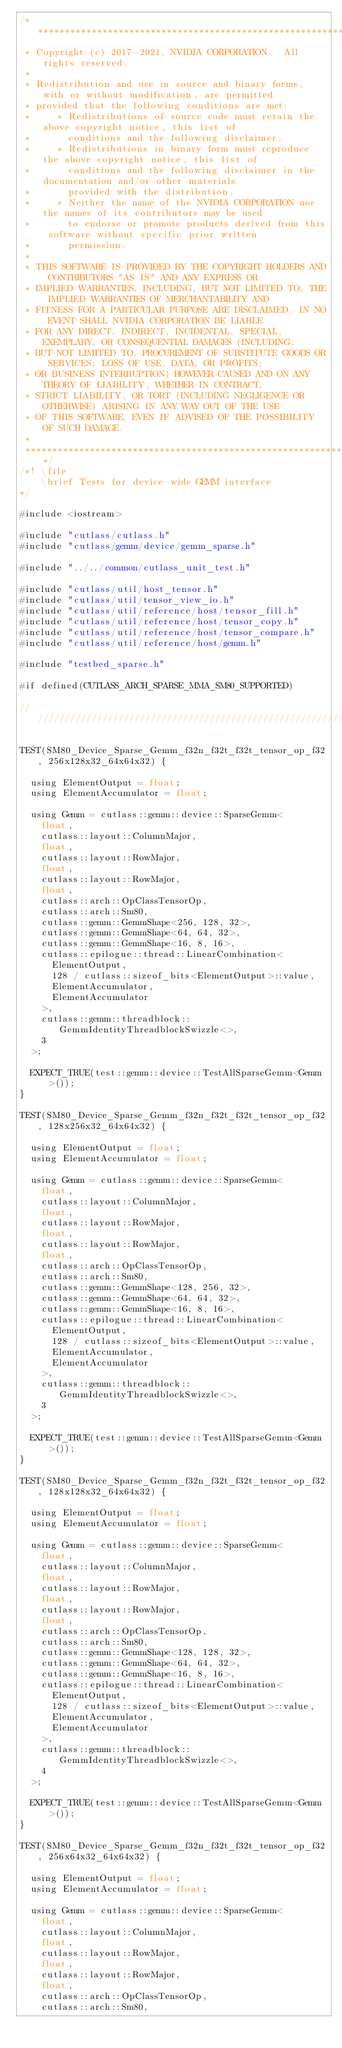<code> <loc_0><loc_0><loc_500><loc_500><_Cuda_>/***************************************************************************************************
 * Copyright (c) 2017-2021, NVIDIA CORPORATION.  All rights reserved.
 *
 * Redistribution and use in source and binary forms, with or without modification, are permitted
 * provided that the following conditions are met:
 *     * Redistributions of source code must retain the above copyright notice, this list of
 *       conditions and the following disclaimer.
 *     * Redistributions in binary form must reproduce the above copyright notice, this list of
 *       conditions and the following disclaimer in the documentation and/or other materials
 *       provided with the distribution.
 *     * Neither the name of the NVIDIA CORPORATION nor the names of its contributors may be used
 *       to endorse or promote products derived from this software without specific prior written
 *       permission.
 *
 * THIS SOFTWARE IS PROVIDED BY THE COPYRIGHT HOLDERS AND CONTRIBUTORS "AS IS" AND ANY EXPRESS OR
 * IMPLIED WARRANTIES, INCLUDING, BUT NOT LIMITED TO, THE IMPLIED WARRANTIES OF MERCHANTABILITY AND
 * FITNESS FOR A PARTICULAR PURPOSE ARE DISCLAIMED. IN NO EVENT SHALL NVIDIA CORPORATION BE LIABLE
 * FOR ANY DIRECT, INDIRECT, INCIDENTAL, SPECIAL, EXEMPLARY, OR CONSEQUENTIAL DAMAGES (INCLUDING,
 * BUT NOT LIMITED TO, PROCUREMENT OF SUBSTITUTE GOODS OR SERVICES; LOSS OF USE, DATA, OR PROFITS;
 * OR BUSINESS INTERRUPTION) HOWEVER CAUSED AND ON ANY THEORY OF LIABILITY, WHETHER IN CONTRACT,
 * STRICT LIABILITY, OR TORT (INCLUDING NEGLIGENCE OR OTHERWISE) ARISING IN ANY WAY OUT OF THE USE
 * OF THIS SOFTWARE, EVEN IF ADVISED OF THE POSSIBILITY OF SUCH DAMAGE.
 *
 **************************************************************************************************/
/*! \file
    \brief Tests for device-wide GEMM interface
*/

#include <iostream>

#include "cutlass/cutlass.h"
#include "cutlass/gemm/device/gemm_sparse.h"

#include "../../common/cutlass_unit_test.h"

#include "cutlass/util/host_tensor.h"
#include "cutlass/util/tensor_view_io.h"
#include "cutlass/util/reference/host/tensor_fill.h"
#include "cutlass/util/reference/host/tensor_copy.h"
#include "cutlass/util/reference/host/tensor_compare.h"
#include "cutlass/util/reference/host/gemm.h"

#include "testbed_sparse.h"

#if defined(CUTLASS_ARCH_SPARSE_MMA_SM80_SUPPORTED)

/////////////////////////////////////////////////////////////////////////////////////////////////

TEST(SM80_Device_Sparse_Gemm_f32n_f32t_f32t_tensor_op_f32, 256x128x32_64x64x32) {

  using ElementOutput = float;
  using ElementAccumulator = float;

  using Gemm = cutlass::gemm::device::SparseGemm<
    float,
    cutlass::layout::ColumnMajor,
    float,
    cutlass::layout::RowMajor,
    float,
    cutlass::layout::RowMajor,
    float,
    cutlass::arch::OpClassTensorOp,
    cutlass::arch::Sm80,
    cutlass::gemm::GemmShape<256, 128, 32>,
    cutlass::gemm::GemmShape<64, 64, 32>,
    cutlass::gemm::GemmShape<16, 8, 16>,
    cutlass::epilogue::thread::LinearCombination<
      ElementOutput,
      128 / cutlass::sizeof_bits<ElementOutput>::value,
      ElementAccumulator,
      ElementAccumulator
    >,
    cutlass::gemm::threadblock::GemmIdentityThreadblockSwizzle<>,
    3
  >;

  EXPECT_TRUE(test::gemm::device::TestAllSparseGemm<Gemm>());
}

TEST(SM80_Device_Sparse_Gemm_f32n_f32t_f32t_tensor_op_f32, 128x256x32_64x64x32) {

  using ElementOutput = float;
  using ElementAccumulator = float;

  using Gemm = cutlass::gemm::device::SparseGemm<
    float,
    cutlass::layout::ColumnMajor,
    float,
    cutlass::layout::RowMajor,
    float,
    cutlass::layout::RowMajor,
    float,
    cutlass::arch::OpClassTensorOp,
    cutlass::arch::Sm80,
    cutlass::gemm::GemmShape<128, 256, 32>,
    cutlass::gemm::GemmShape<64, 64, 32>,
    cutlass::gemm::GemmShape<16, 8, 16>,
    cutlass::epilogue::thread::LinearCombination<
      ElementOutput,
      128 / cutlass::sizeof_bits<ElementOutput>::value,
      ElementAccumulator,
      ElementAccumulator
    >,
    cutlass::gemm::threadblock::GemmIdentityThreadblockSwizzle<>,
    3
  >;

  EXPECT_TRUE(test::gemm::device::TestAllSparseGemm<Gemm>());
}

TEST(SM80_Device_Sparse_Gemm_f32n_f32t_f32t_tensor_op_f32, 128x128x32_64x64x32) {

  using ElementOutput = float;
  using ElementAccumulator = float;

  using Gemm = cutlass::gemm::device::SparseGemm<
    float,
    cutlass::layout::ColumnMajor,
    float,
    cutlass::layout::RowMajor,
    float,
    cutlass::layout::RowMajor,
    float,
    cutlass::arch::OpClassTensorOp,
    cutlass::arch::Sm80,
    cutlass::gemm::GemmShape<128, 128, 32>,
    cutlass::gemm::GemmShape<64, 64, 32>,
    cutlass::gemm::GemmShape<16, 8, 16>,
    cutlass::epilogue::thread::LinearCombination<
      ElementOutput,
      128 / cutlass::sizeof_bits<ElementOutput>::value,
      ElementAccumulator,
      ElementAccumulator
    >,
    cutlass::gemm::threadblock::GemmIdentityThreadblockSwizzle<>,
    4 
  >;

  EXPECT_TRUE(test::gemm::device::TestAllSparseGemm<Gemm>());
}

TEST(SM80_Device_Sparse_Gemm_f32n_f32t_f32t_tensor_op_f32, 256x64x32_64x64x32) {

  using ElementOutput = float;
  using ElementAccumulator = float;

  using Gemm = cutlass::gemm::device::SparseGemm<
    float,
    cutlass::layout::ColumnMajor,
    float,
    cutlass::layout::RowMajor,
    float,
    cutlass::layout::RowMajor,
    float,
    cutlass::arch::OpClassTensorOp,
    cutlass::arch::Sm80,</code> 